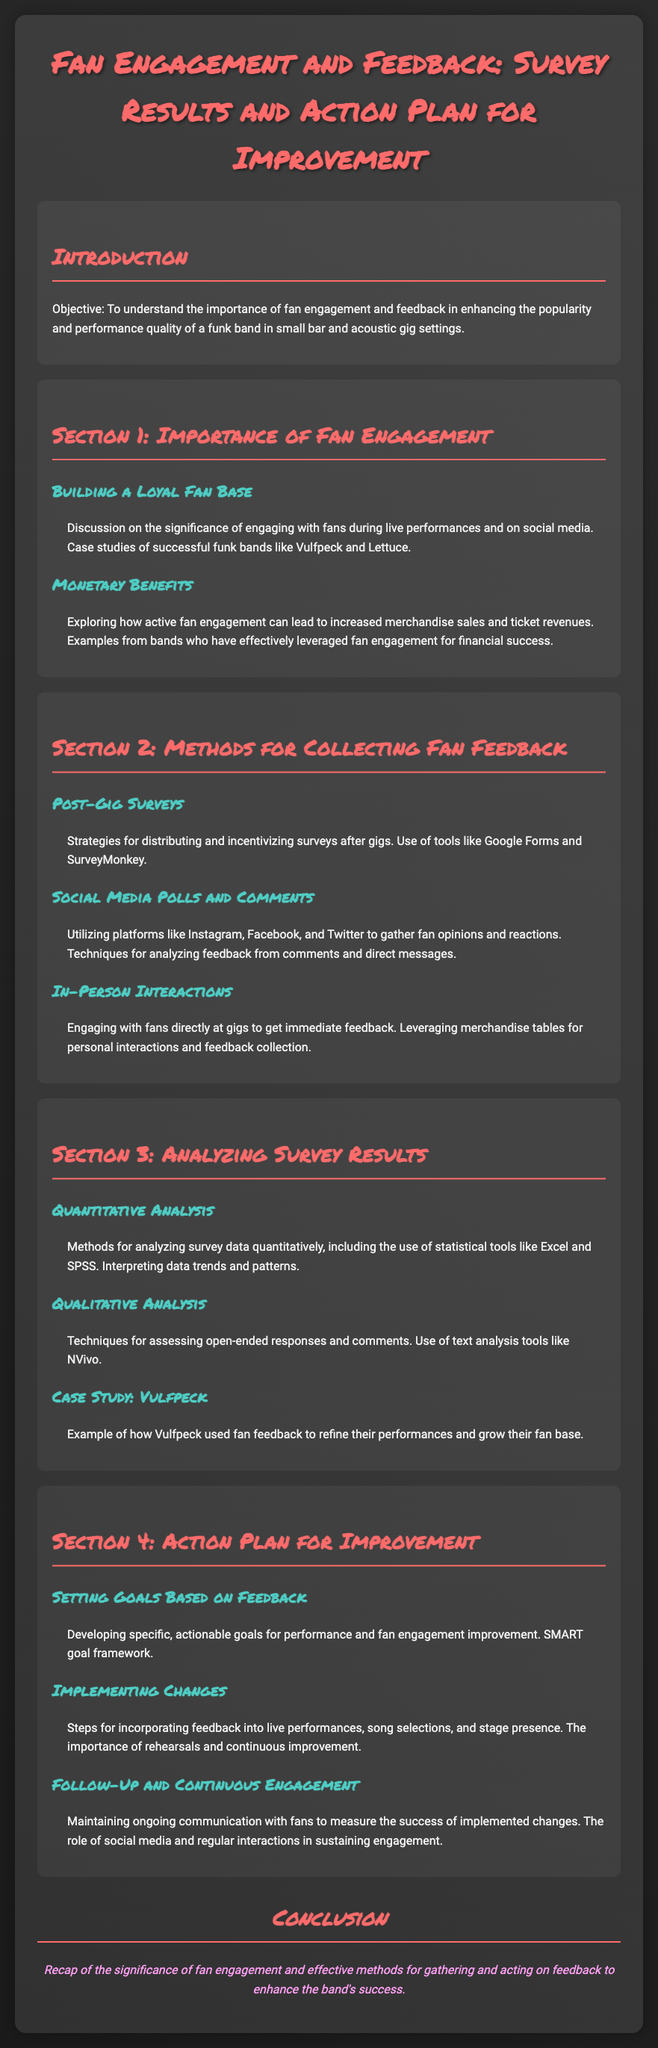what is the title of the document? The title of the document is clearly mentioned at the top as "Fan Engagement and Feedback: Survey Results and Action Plan for Improvement."
Answer: Fan Engagement and Feedback: Survey Results and Action Plan for Improvement who are examples of successful funk bands mentioned? The document specifically cites Vulfpeck and Lettuce as successful funk bands that illustrate the importance of fan engagement.
Answer: Vulfpeck and Lettuce what is one method for collecting fan feedback? The document outlines several methods, one of which is "Post-Gig Surveys."
Answer: Post-Gig Surveys what does the SMART framework refer to? The SMART framework is mentioned in Section 4 as a tool for developing specific, actionable goals based on feedback for performance improvement.
Answer: Specific, Measurable, Achievable, Relevant, Time-bound which social media platforms are suggested for gathering fan opinions? The document lists Instagram, Facebook, and Twitter as platforms to gather opinions and reactions from fans.
Answer: Instagram, Facebook, and Twitter what is discussed in the "Case Study: Vulfpeck"? The document provides an example of how Vulfpeck used fan feedback to enhance their performances and grow their audience.
Answer: Fan feedback to refine performances what is the goal of maintaining ongoing communication with fans? The document states that ongoing communication is to measure the success of implemented changes and sustain engagement with fans.
Answer: Measure success and sustain engagement how should feedback be incorporated into performances? The document suggests that feedback should be incorporated through changes in live performances, song selections, and stage presence.
Answer: Changes in live performances, song selections, and stage presence 